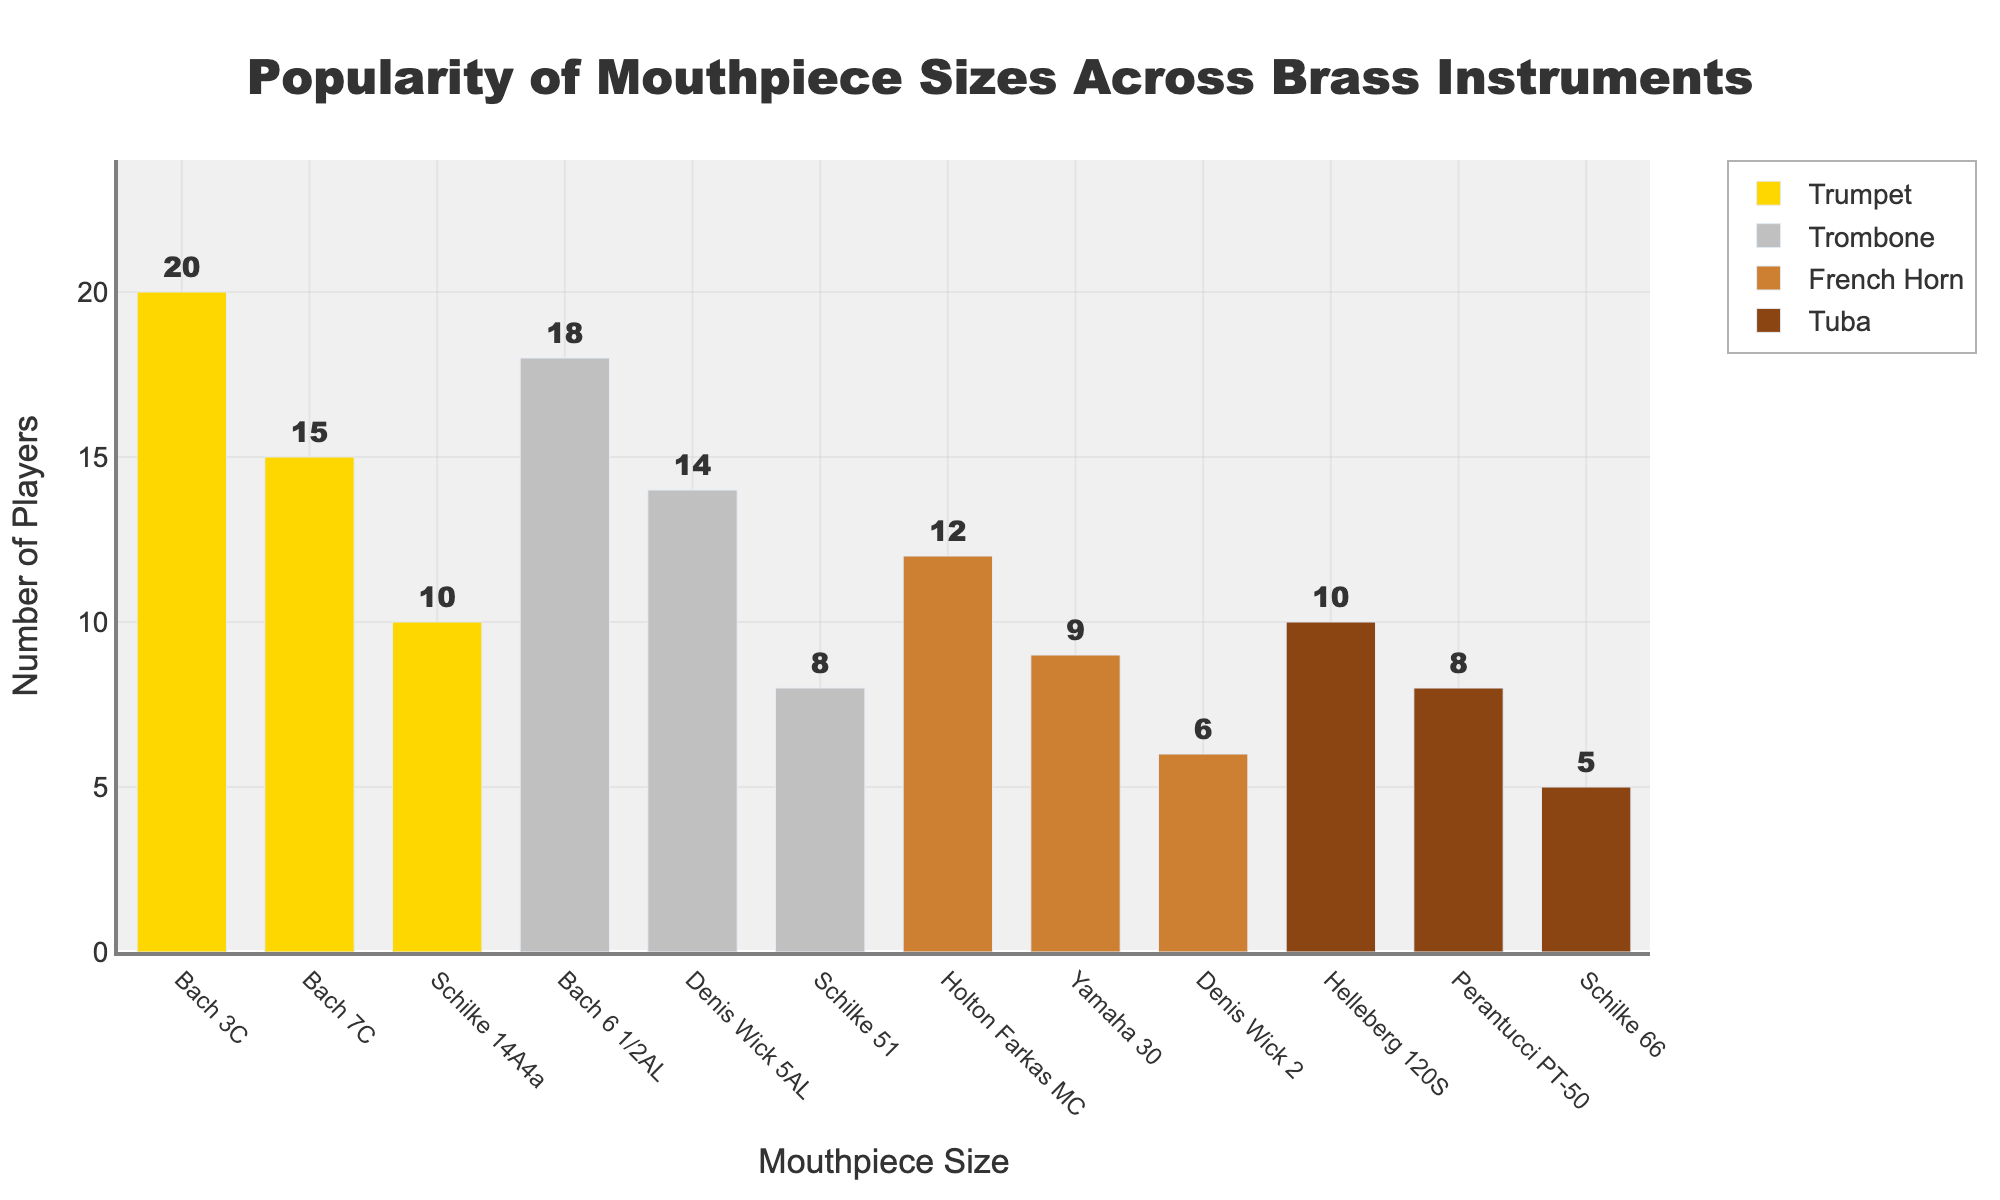What is the most popular mouthpiece size for trumpet players? The bar representing the "Bach 3C" mouthpiece size for Trumpet reaches the highest point at 20 players, making it the most popular.
Answer: Bach 3C Which instrument has the mouthpiece with the least popularity? The "Schilke 66" mouthpiece for Tuba has the lowest bar at 5 players, indicating the least popularity.
Answer: Tuba What is the combined popularity of the two most popular trombone mouthpieces? The Bach 6 1/2AL and Denis Wick 5AL mouthpieces for Trombone have 18 and 14 players respectively. Adding these gives 18 + 14 = 32 players.
Answer: 32 Are there more tuba players using the Helleberg 120S or trumpet players using the Schilke 14A4a? There are 10 players using the Helleberg 120S tuba mouthpiece and 10 players using the Schilke 14A4a trumpet mouthpiece. Since these numbers are equal, neither has more players.
Answer: Equal Which instrument has the most even distribution of mouthpiece popularity? The French Horn mouthpieces show popularity counts of 12, 9, and 6, which are fairly close compared to other instruments with more varied counts.
Answer: French Horn How many more players use the most popular trumpet mouthpiece compared to the least popular trombone mouthpiece? The most popular trumpet mouthpiece, Bach 3C, has 20 players, and the least popular trombone mouthpiece, Schilke 51, has 8 players. The difference is 20 - 8 = 12 players.
Answer: 12 What percentage of French Horn players use the Holton Farkas MC mouthpiece? The Holton Farkas MC mouthpiece has 12 players out of the total 27 French Horn players (12 + 9 + 6). The percentage is (12 / 27) * 100 ≈ 44.44%.
Answer: 44.44% Rank the trombone mouthpieces by their popularity from most to least. Ranking the trombone mouthpieces: Bach 6 1/2AL (18), Denis Wick 5AL (14), Schilke 51 (8).
Answer: Bach 6 1/2AL, Denis Wick 5AL, Schilke 51 Which mouthpiece size has the highest combined popularity across all instruments? Summing all instrument categories for each mouthpiece, Bach 3C for Trumpet has the highest total, being the most popular individual mouthpiece across Trumpet with 20 players. The next highest would be other individuals, but none combine in aggregate across categories this clearly.
Answer: Bach 3C 